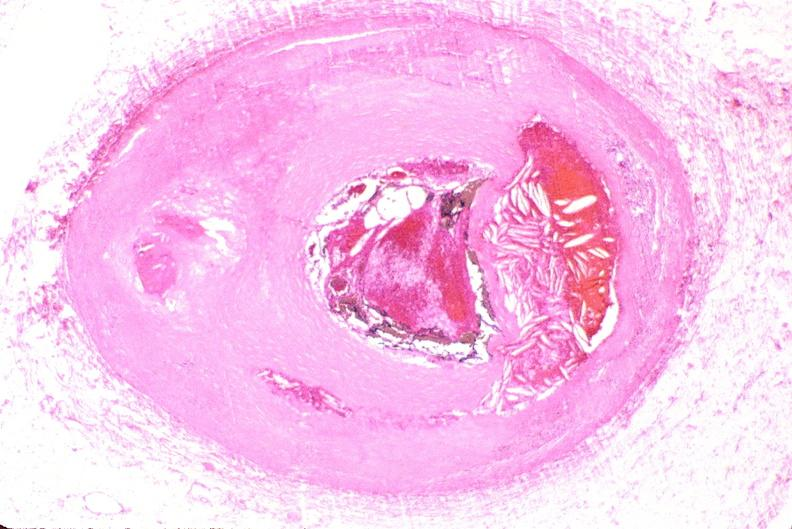does this image show right coronary artery, atherosclerosis and acute thrombus?
Answer the question using a single word or phrase. Yes 